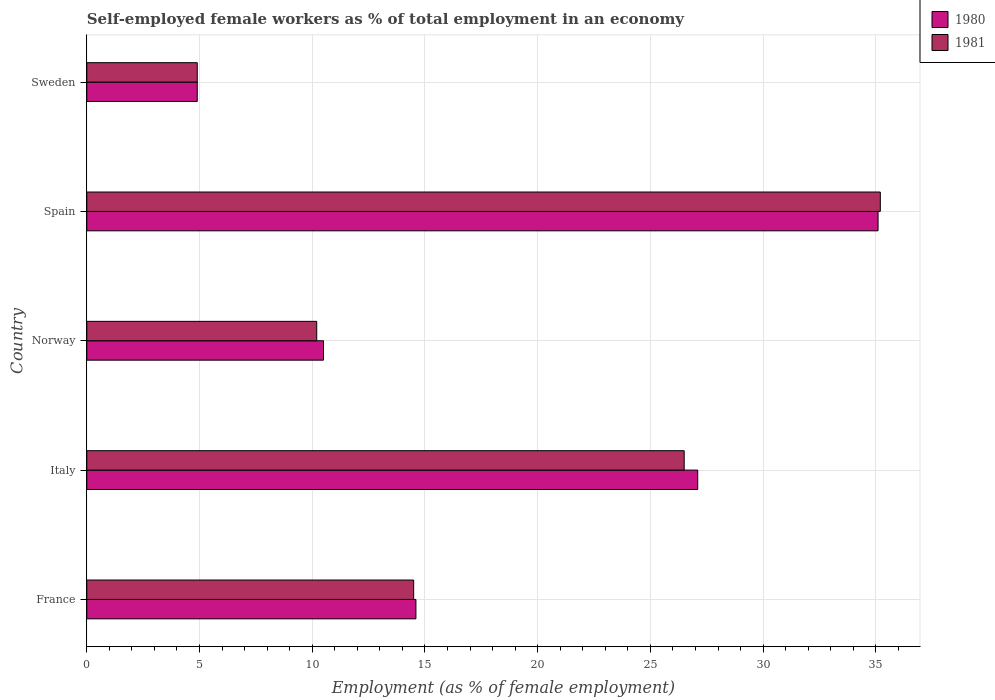Are the number of bars per tick equal to the number of legend labels?
Ensure brevity in your answer.  Yes. Are the number of bars on each tick of the Y-axis equal?
Provide a succinct answer. Yes. How many bars are there on the 3rd tick from the top?
Ensure brevity in your answer.  2. What is the label of the 2nd group of bars from the top?
Your answer should be compact. Spain. What is the percentage of self-employed female workers in 1980 in Sweden?
Your answer should be very brief. 4.9. Across all countries, what is the maximum percentage of self-employed female workers in 1980?
Your answer should be compact. 35.1. Across all countries, what is the minimum percentage of self-employed female workers in 1981?
Give a very brief answer. 4.9. In which country was the percentage of self-employed female workers in 1980 maximum?
Your answer should be very brief. Spain. In which country was the percentage of self-employed female workers in 1980 minimum?
Give a very brief answer. Sweden. What is the total percentage of self-employed female workers in 1980 in the graph?
Give a very brief answer. 92.2. What is the difference between the percentage of self-employed female workers in 1981 in Spain and that in Sweden?
Offer a very short reply. 30.3. What is the difference between the percentage of self-employed female workers in 1980 in Spain and the percentage of self-employed female workers in 1981 in France?
Give a very brief answer. 20.6. What is the average percentage of self-employed female workers in 1980 per country?
Keep it short and to the point. 18.44. What is the difference between the percentage of self-employed female workers in 1980 and percentage of self-employed female workers in 1981 in Norway?
Your answer should be very brief. 0.3. In how many countries, is the percentage of self-employed female workers in 1980 greater than 23 %?
Ensure brevity in your answer.  2. What is the ratio of the percentage of self-employed female workers in 1981 in France to that in Sweden?
Ensure brevity in your answer.  2.96. What is the difference between the highest and the second highest percentage of self-employed female workers in 1981?
Your answer should be very brief. 8.7. What is the difference between the highest and the lowest percentage of self-employed female workers in 1980?
Make the answer very short. 30.2. In how many countries, is the percentage of self-employed female workers in 1981 greater than the average percentage of self-employed female workers in 1981 taken over all countries?
Give a very brief answer. 2. Is the sum of the percentage of self-employed female workers in 1980 in Norway and Spain greater than the maximum percentage of self-employed female workers in 1981 across all countries?
Make the answer very short. Yes. What does the 2nd bar from the top in France represents?
Provide a short and direct response. 1980. Are the values on the major ticks of X-axis written in scientific E-notation?
Your answer should be very brief. No. Does the graph contain any zero values?
Give a very brief answer. No. Does the graph contain grids?
Your answer should be compact. Yes. How many legend labels are there?
Your answer should be very brief. 2. How are the legend labels stacked?
Provide a short and direct response. Vertical. What is the title of the graph?
Your response must be concise. Self-employed female workers as % of total employment in an economy. Does "2003" appear as one of the legend labels in the graph?
Your answer should be very brief. No. What is the label or title of the X-axis?
Give a very brief answer. Employment (as % of female employment). What is the label or title of the Y-axis?
Provide a short and direct response. Country. What is the Employment (as % of female employment) in 1980 in France?
Your response must be concise. 14.6. What is the Employment (as % of female employment) of 1981 in France?
Your answer should be very brief. 14.5. What is the Employment (as % of female employment) in 1980 in Italy?
Give a very brief answer. 27.1. What is the Employment (as % of female employment) of 1981 in Italy?
Your response must be concise. 26.5. What is the Employment (as % of female employment) of 1981 in Norway?
Your answer should be very brief. 10.2. What is the Employment (as % of female employment) in 1980 in Spain?
Your answer should be compact. 35.1. What is the Employment (as % of female employment) in 1981 in Spain?
Provide a succinct answer. 35.2. What is the Employment (as % of female employment) in 1980 in Sweden?
Provide a succinct answer. 4.9. What is the Employment (as % of female employment) in 1981 in Sweden?
Ensure brevity in your answer.  4.9. Across all countries, what is the maximum Employment (as % of female employment) of 1980?
Provide a succinct answer. 35.1. Across all countries, what is the maximum Employment (as % of female employment) in 1981?
Ensure brevity in your answer.  35.2. Across all countries, what is the minimum Employment (as % of female employment) of 1980?
Your answer should be very brief. 4.9. Across all countries, what is the minimum Employment (as % of female employment) of 1981?
Keep it short and to the point. 4.9. What is the total Employment (as % of female employment) in 1980 in the graph?
Your answer should be very brief. 92.2. What is the total Employment (as % of female employment) in 1981 in the graph?
Give a very brief answer. 91.3. What is the difference between the Employment (as % of female employment) in 1980 in France and that in Norway?
Your answer should be very brief. 4.1. What is the difference between the Employment (as % of female employment) of 1981 in France and that in Norway?
Provide a short and direct response. 4.3. What is the difference between the Employment (as % of female employment) in 1980 in France and that in Spain?
Your answer should be very brief. -20.5. What is the difference between the Employment (as % of female employment) in 1981 in France and that in Spain?
Provide a short and direct response. -20.7. What is the difference between the Employment (as % of female employment) of 1980 in France and that in Sweden?
Your answer should be compact. 9.7. What is the difference between the Employment (as % of female employment) of 1980 in Italy and that in Norway?
Keep it short and to the point. 16.6. What is the difference between the Employment (as % of female employment) in 1980 in Italy and that in Sweden?
Your answer should be very brief. 22.2. What is the difference between the Employment (as % of female employment) in 1981 in Italy and that in Sweden?
Your response must be concise. 21.6. What is the difference between the Employment (as % of female employment) of 1980 in Norway and that in Spain?
Offer a very short reply. -24.6. What is the difference between the Employment (as % of female employment) in 1980 in Spain and that in Sweden?
Your answer should be compact. 30.2. What is the difference between the Employment (as % of female employment) in 1981 in Spain and that in Sweden?
Your response must be concise. 30.3. What is the difference between the Employment (as % of female employment) of 1980 in France and the Employment (as % of female employment) of 1981 in Norway?
Keep it short and to the point. 4.4. What is the difference between the Employment (as % of female employment) in 1980 in France and the Employment (as % of female employment) in 1981 in Spain?
Give a very brief answer. -20.6. What is the difference between the Employment (as % of female employment) in 1980 in Italy and the Employment (as % of female employment) in 1981 in Spain?
Ensure brevity in your answer.  -8.1. What is the difference between the Employment (as % of female employment) of 1980 in Italy and the Employment (as % of female employment) of 1981 in Sweden?
Keep it short and to the point. 22.2. What is the difference between the Employment (as % of female employment) in 1980 in Norway and the Employment (as % of female employment) in 1981 in Spain?
Offer a very short reply. -24.7. What is the difference between the Employment (as % of female employment) in 1980 in Norway and the Employment (as % of female employment) in 1981 in Sweden?
Provide a succinct answer. 5.6. What is the difference between the Employment (as % of female employment) in 1980 in Spain and the Employment (as % of female employment) in 1981 in Sweden?
Make the answer very short. 30.2. What is the average Employment (as % of female employment) in 1980 per country?
Your answer should be compact. 18.44. What is the average Employment (as % of female employment) in 1981 per country?
Offer a terse response. 18.26. What is the difference between the Employment (as % of female employment) in 1980 and Employment (as % of female employment) in 1981 in France?
Offer a very short reply. 0.1. What is the ratio of the Employment (as % of female employment) in 1980 in France to that in Italy?
Give a very brief answer. 0.54. What is the ratio of the Employment (as % of female employment) of 1981 in France to that in Italy?
Keep it short and to the point. 0.55. What is the ratio of the Employment (as % of female employment) of 1980 in France to that in Norway?
Your response must be concise. 1.39. What is the ratio of the Employment (as % of female employment) of 1981 in France to that in Norway?
Ensure brevity in your answer.  1.42. What is the ratio of the Employment (as % of female employment) in 1980 in France to that in Spain?
Provide a succinct answer. 0.42. What is the ratio of the Employment (as % of female employment) in 1981 in France to that in Spain?
Provide a short and direct response. 0.41. What is the ratio of the Employment (as % of female employment) in 1980 in France to that in Sweden?
Give a very brief answer. 2.98. What is the ratio of the Employment (as % of female employment) in 1981 in France to that in Sweden?
Make the answer very short. 2.96. What is the ratio of the Employment (as % of female employment) in 1980 in Italy to that in Norway?
Offer a terse response. 2.58. What is the ratio of the Employment (as % of female employment) in 1981 in Italy to that in Norway?
Your answer should be compact. 2.6. What is the ratio of the Employment (as % of female employment) in 1980 in Italy to that in Spain?
Offer a very short reply. 0.77. What is the ratio of the Employment (as % of female employment) of 1981 in Italy to that in Spain?
Provide a short and direct response. 0.75. What is the ratio of the Employment (as % of female employment) in 1980 in Italy to that in Sweden?
Provide a succinct answer. 5.53. What is the ratio of the Employment (as % of female employment) of 1981 in Italy to that in Sweden?
Keep it short and to the point. 5.41. What is the ratio of the Employment (as % of female employment) in 1980 in Norway to that in Spain?
Offer a very short reply. 0.3. What is the ratio of the Employment (as % of female employment) of 1981 in Norway to that in Spain?
Offer a terse response. 0.29. What is the ratio of the Employment (as % of female employment) in 1980 in Norway to that in Sweden?
Offer a very short reply. 2.14. What is the ratio of the Employment (as % of female employment) of 1981 in Norway to that in Sweden?
Your answer should be very brief. 2.08. What is the ratio of the Employment (as % of female employment) in 1980 in Spain to that in Sweden?
Your answer should be compact. 7.16. What is the ratio of the Employment (as % of female employment) of 1981 in Spain to that in Sweden?
Keep it short and to the point. 7.18. What is the difference between the highest and the second highest Employment (as % of female employment) in 1980?
Provide a succinct answer. 8. What is the difference between the highest and the lowest Employment (as % of female employment) in 1980?
Your answer should be very brief. 30.2. What is the difference between the highest and the lowest Employment (as % of female employment) of 1981?
Provide a short and direct response. 30.3. 